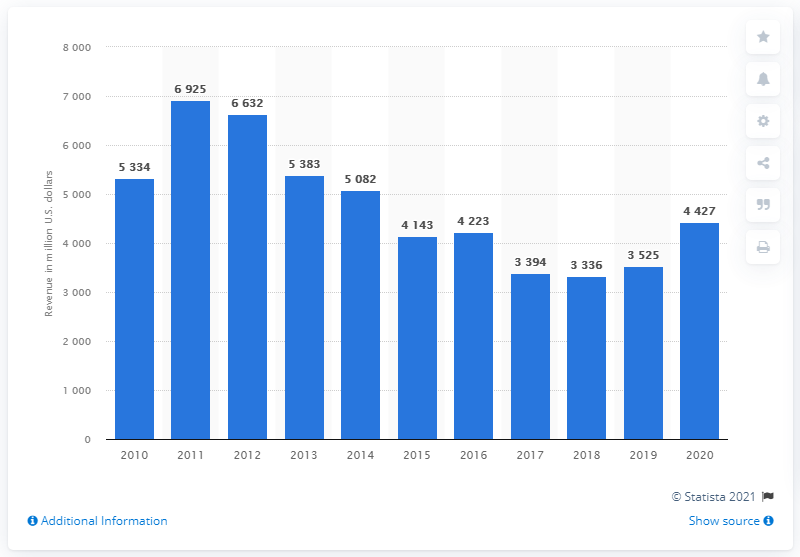Identify some key points in this picture. AngloGold Ashanti generated approximately $442.7 million in revenue in the United States in 2020. 